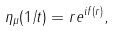Convert formula to latex. <formula><loc_0><loc_0><loc_500><loc_500>\eta _ { \mu } ( 1 / t ) = r e ^ { i f ( r ) } ,</formula> 